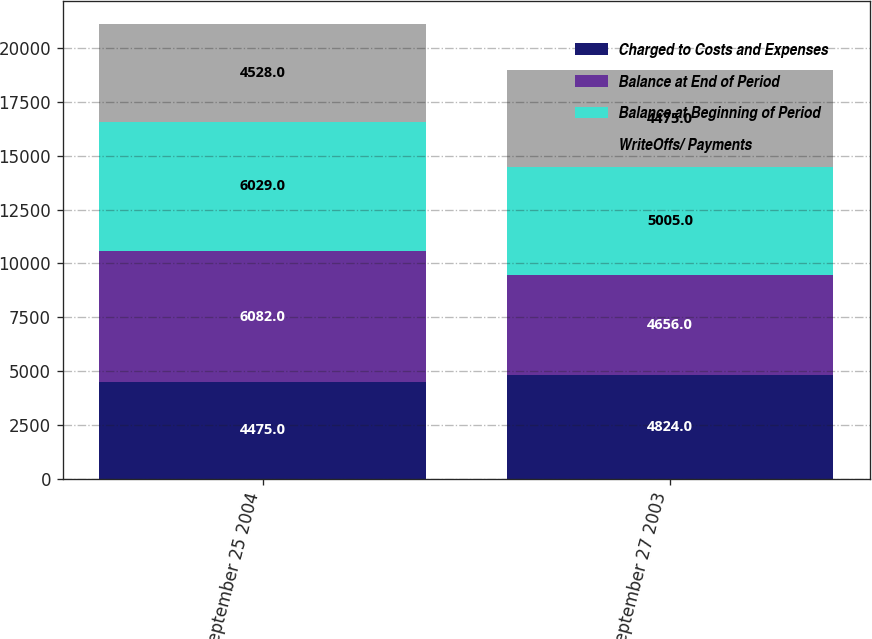Convert chart to OTSL. <chart><loc_0><loc_0><loc_500><loc_500><stacked_bar_chart><ecel><fcel>September 25 2004<fcel>September 27 2003<nl><fcel>Charged to Costs and Expenses<fcel>4475<fcel>4824<nl><fcel>Balance at End of Period<fcel>6082<fcel>4656<nl><fcel>Balance at Beginning of Period<fcel>6029<fcel>5005<nl><fcel>WriteOffs/ Payments<fcel>4528<fcel>4475<nl></chart> 